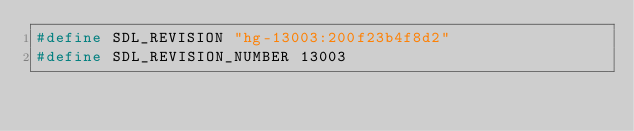Convert code to text. <code><loc_0><loc_0><loc_500><loc_500><_C_>#define SDL_REVISION "hg-13003:200f23b4f8d2"
#define SDL_REVISION_NUMBER 13003
</code> 